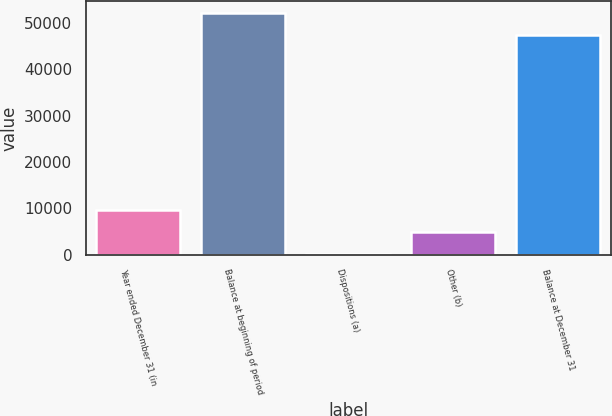Convert chart to OTSL. <chart><loc_0><loc_0><loc_500><loc_500><bar_chart><fcel>Year ended December 31 (in<fcel>Balance at beginning of period<fcel>Dispositions (a)<fcel>Other (b)<fcel>Balance at December 31<nl><fcel>9657.4<fcel>52073.7<fcel>160<fcel>4908.7<fcel>47325<nl></chart> 